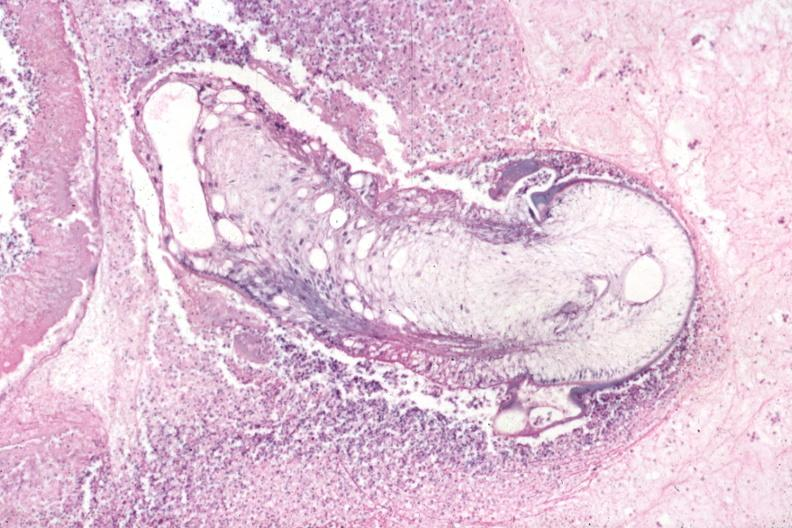s cysticercosis present?
Answer the question using a single word or phrase. Yes 